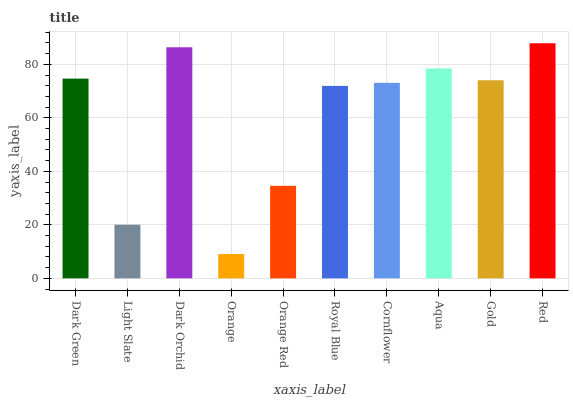Is Orange the minimum?
Answer yes or no. Yes. Is Red the maximum?
Answer yes or no. Yes. Is Light Slate the minimum?
Answer yes or no. No. Is Light Slate the maximum?
Answer yes or no. No. Is Dark Green greater than Light Slate?
Answer yes or no. Yes. Is Light Slate less than Dark Green?
Answer yes or no. Yes. Is Light Slate greater than Dark Green?
Answer yes or no. No. Is Dark Green less than Light Slate?
Answer yes or no. No. Is Gold the high median?
Answer yes or no. Yes. Is Cornflower the low median?
Answer yes or no. Yes. Is Orange the high median?
Answer yes or no. No. Is Red the low median?
Answer yes or no. No. 